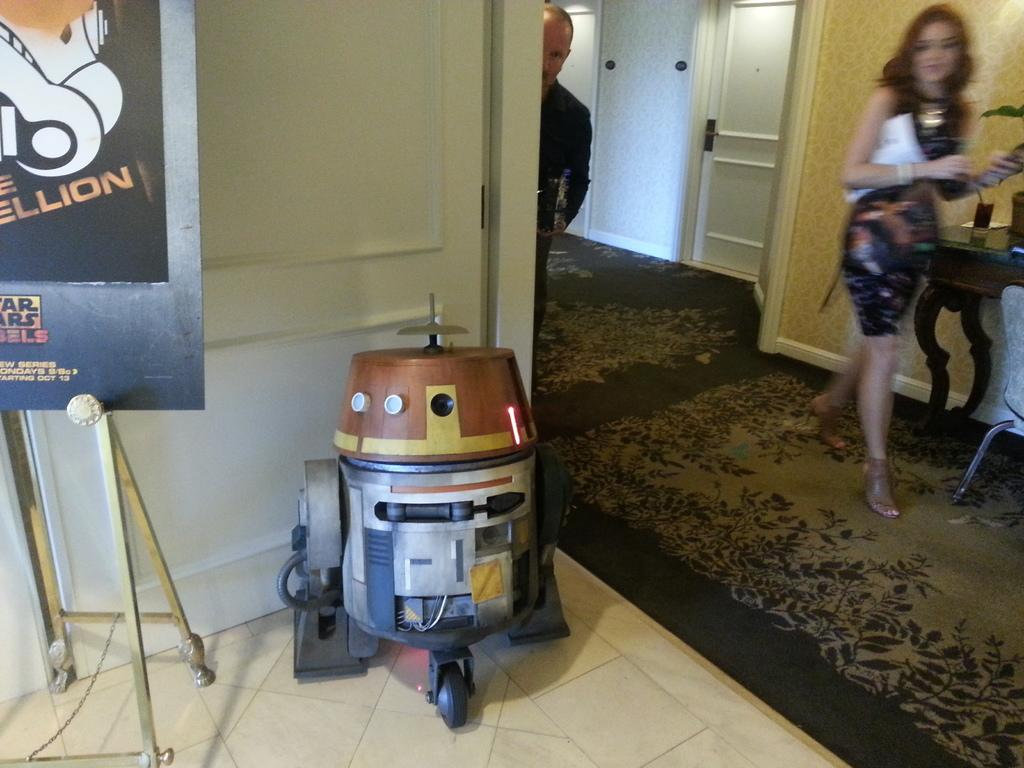<image>
Present a compact description of the photo's key features. A poster that is advertising for a Star Wars series 